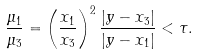Convert formula to latex. <formula><loc_0><loc_0><loc_500><loc_500>\frac { \mu _ { 1 } } { \mu _ { 3 } } = \left ( \frac { x _ { 1 } } { x _ { 3 } } \right ) ^ { 2 } \frac { | y - x _ { 3 } | } { | y - x _ { 1 } | } < \tau .</formula> 